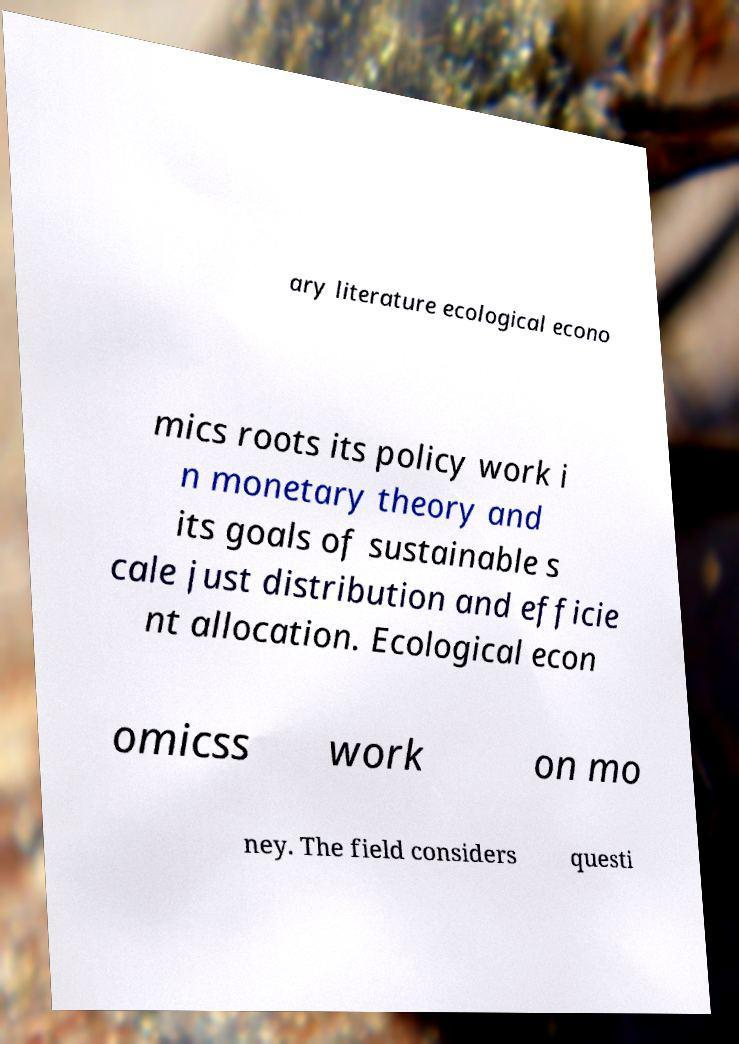Please identify and transcribe the text found in this image. ary literature ecological econo mics roots its policy work i n monetary theory and its goals of sustainable s cale just distribution and efficie nt allocation. Ecological econ omicss work on mo ney. The field considers questi 